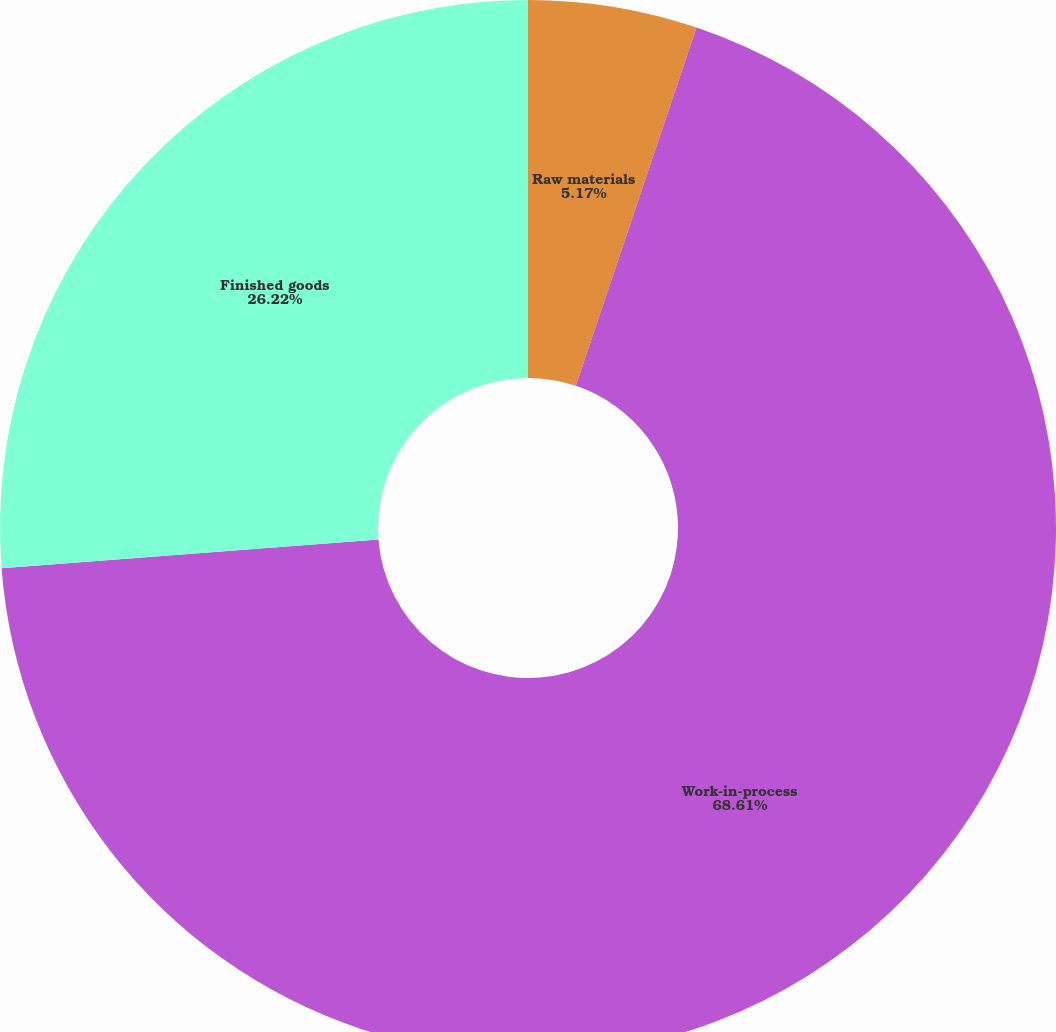Convert chart. <chart><loc_0><loc_0><loc_500><loc_500><pie_chart><fcel>Raw materials<fcel>Work-in-process<fcel>Finished goods<nl><fcel>5.17%<fcel>68.62%<fcel>26.22%<nl></chart> 